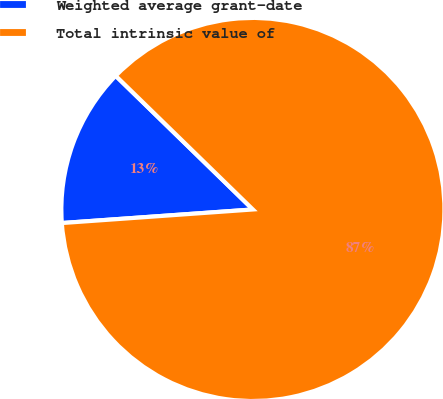Convert chart to OTSL. <chart><loc_0><loc_0><loc_500><loc_500><pie_chart><fcel>Weighted average grant-date<fcel>Total intrinsic value of<nl><fcel>13.42%<fcel>86.58%<nl></chart> 